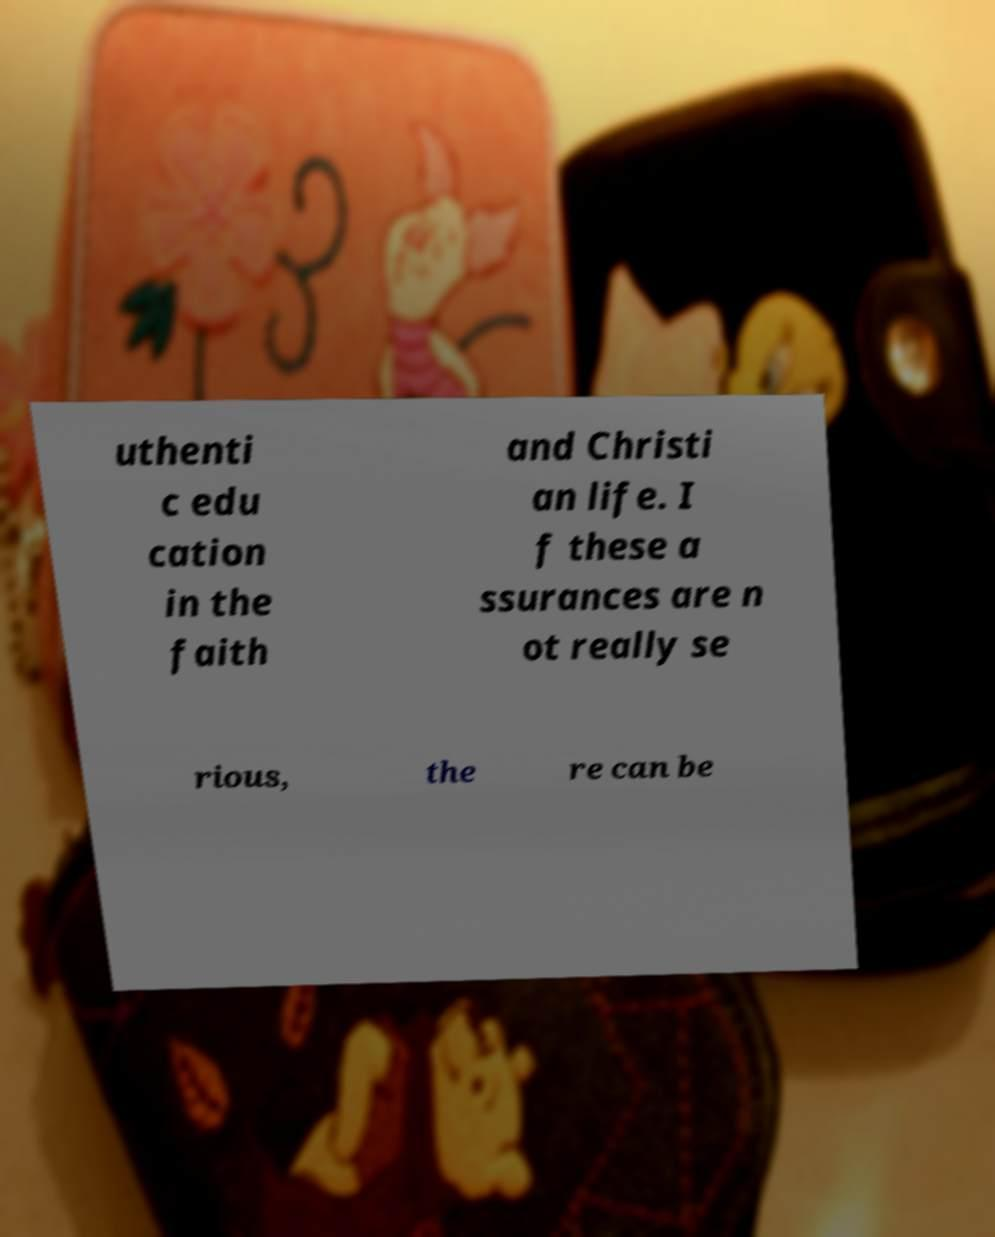Please read and relay the text visible in this image. What does it say? uthenti c edu cation in the faith and Christi an life. I f these a ssurances are n ot really se rious, the re can be 